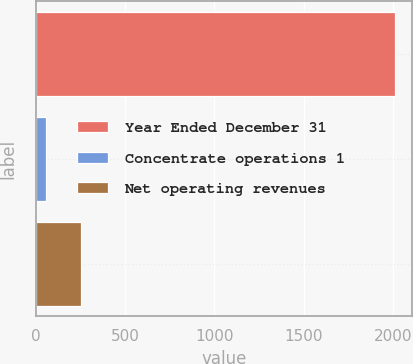Convert chart. <chart><loc_0><loc_0><loc_500><loc_500><bar_chart><fcel>Year Ended December 31<fcel>Concentrate operations 1<fcel>Net operating revenues<nl><fcel>2009<fcel>54<fcel>249.5<nl></chart> 